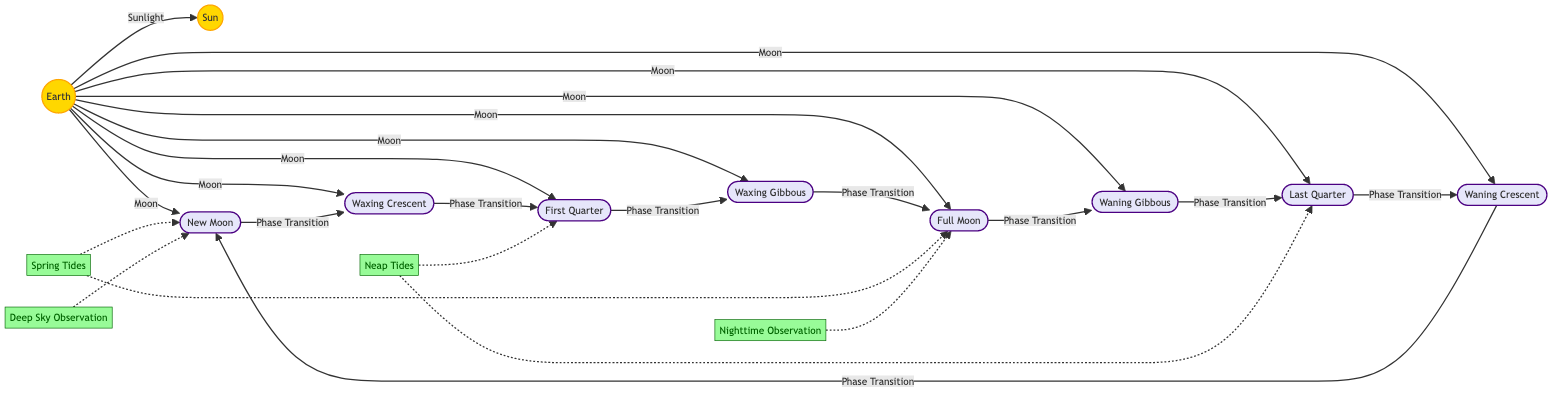What are the eight phases of the moon depicted in the diagram? The diagram shows eight specific phases of the moon: New Moon, Waxing Crescent, First Quarter, Waxing Gibbous, Full Moon, Waning Gibbous, Last Quarter, and Waning Crescent.
Answer: New Moon, Waxing Crescent, First Quarter, Waxing Gibbous, Full Moon, Waning Gibbous, Last Quarter, Waning Crescent Which two phases of the moon are associated with spring tides? The diagram indicates that Spring Tides are related to the New Moon and Full Moon phases, which are highlighted by dashed arrows.
Answer: New Moon, Full Moon What phase comes after Waxing Gibbous? From the diagram, the flow indicates that after the Waxing Gibbous phase transitions the next phase is the Full Moon.
Answer: Full Moon How many nodes represent the moon phases in the diagram? The diagram explicitly lists eight moon phase nodes, which are New Moon, Waxing Crescent, First Quarter, Waxing Gibbous, Full Moon, Waning Gibbous, Last Quarter, and Waning Crescent.
Answer: Eight What kind of observations are suggested during the New Moon phase? The diagram highlights that Deep Sky Observation is suggested during the New Moon phase, which is indicated by a dashed arrow leading to the relevant annotation.
Answer: Deep Sky Observation Which two moon phases cause neap tides? The diagram shows that Neap Tides are associated with the First Quarter and Last Quarter phases, denoted by dashed arrows.
Answer: First Quarter, Last Quarter What transition occurs after the Last Quarter phase? The diagram indicates that after the Last Quarter phase, the transition leads to the Waning Crescent phase.
Answer: Waning Crescent How is the Earth positioned in relation to the Sun during the New Moon phase? The diagram shows that during the New Moon phase, the Earth is between the Sun and the Moon, indicated by the direct line from Earth to the Sun and the arrow representing sunlight direction.
Answer: Earth is between Sun and Moon 